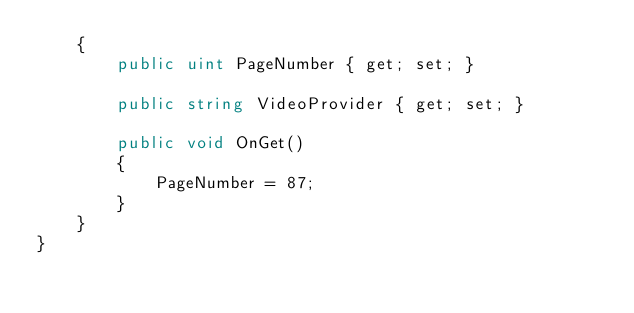Convert code to text. <code><loc_0><loc_0><loc_500><loc_500><_C#_>    {
        public uint PageNumber { get; set; }

        public string VideoProvider { get; set; }

        public void OnGet()
        {
            PageNumber = 87;
        }
    }
}</code> 